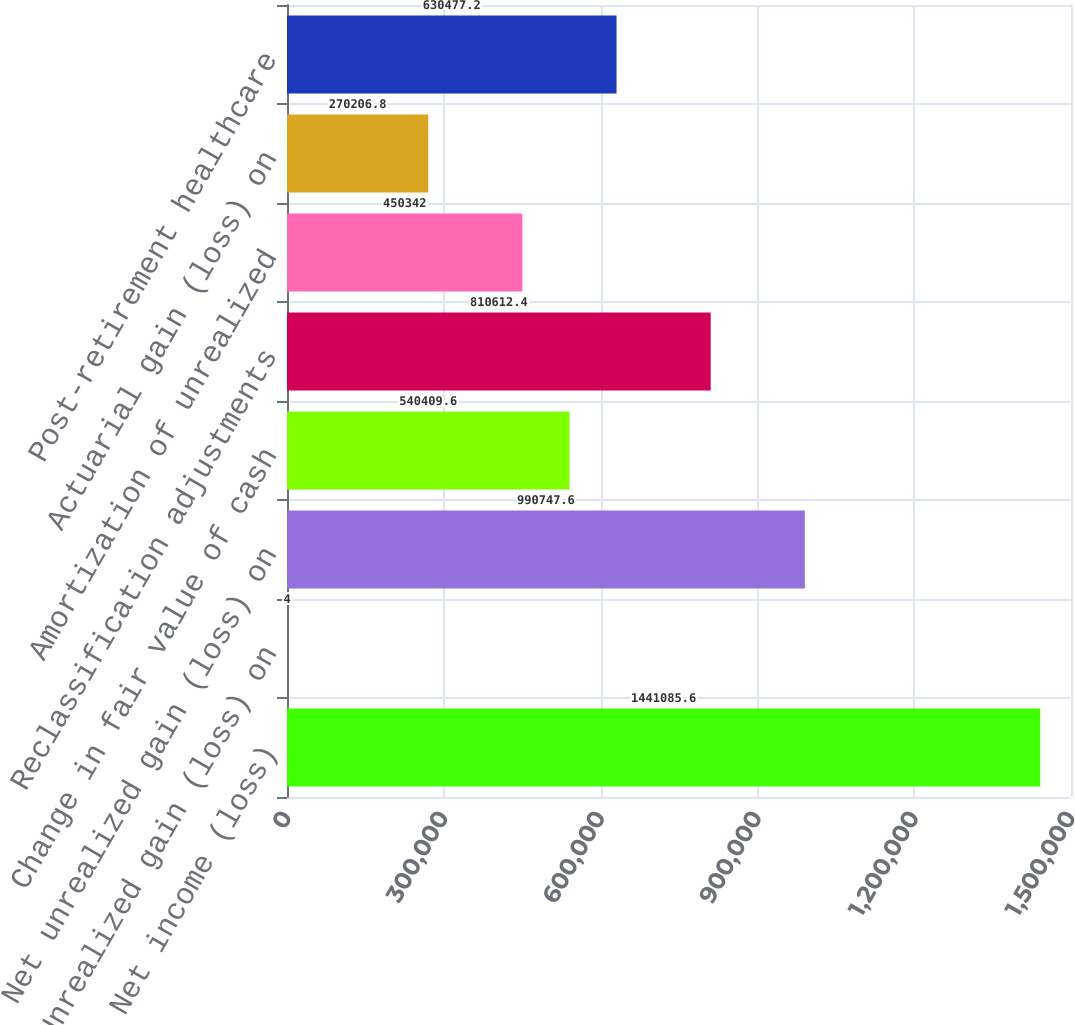<chart> <loc_0><loc_0><loc_500><loc_500><bar_chart><fcel>Net income (loss)<fcel>Unrealized gain (loss) on<fcel>Net unrealized gain (loss) on<fcel>Change in fair value of cash<fcel>Reclassification adjustments<fcel>Amortization of unrealized<fcel>Actuarial gain (loss) on<fcel>Post-retirement healthcare<nl><fcel>1.44109e+06<fcel>4<fcel>990748<fcel>540410<fcel>810612<fcel>450342<fcel>270207<fcel>630477<nl></chart> 